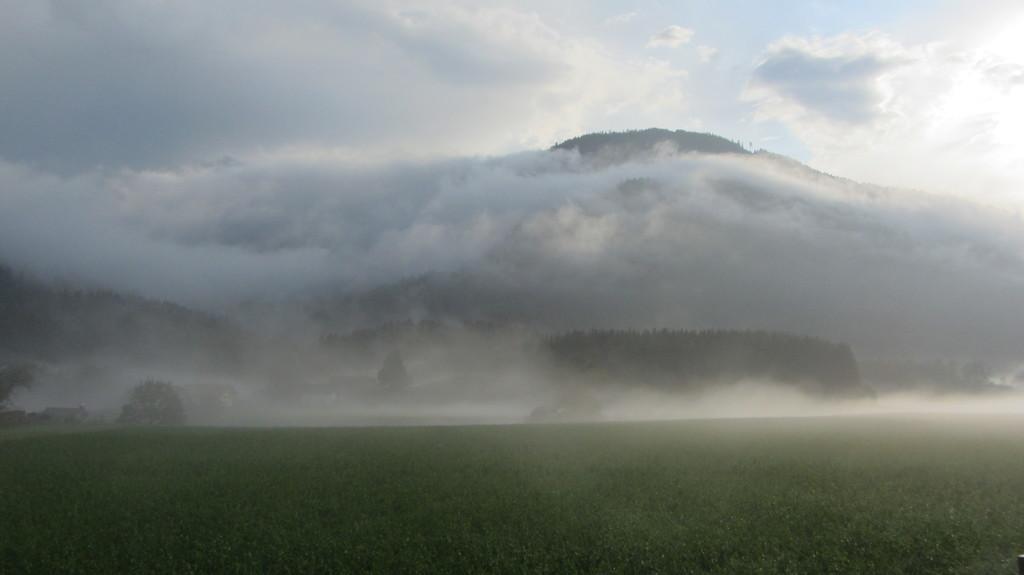In one or two sentences, can you explain what this image depicts? This is ground and there are trees. In the background we can see sky with clouds. 